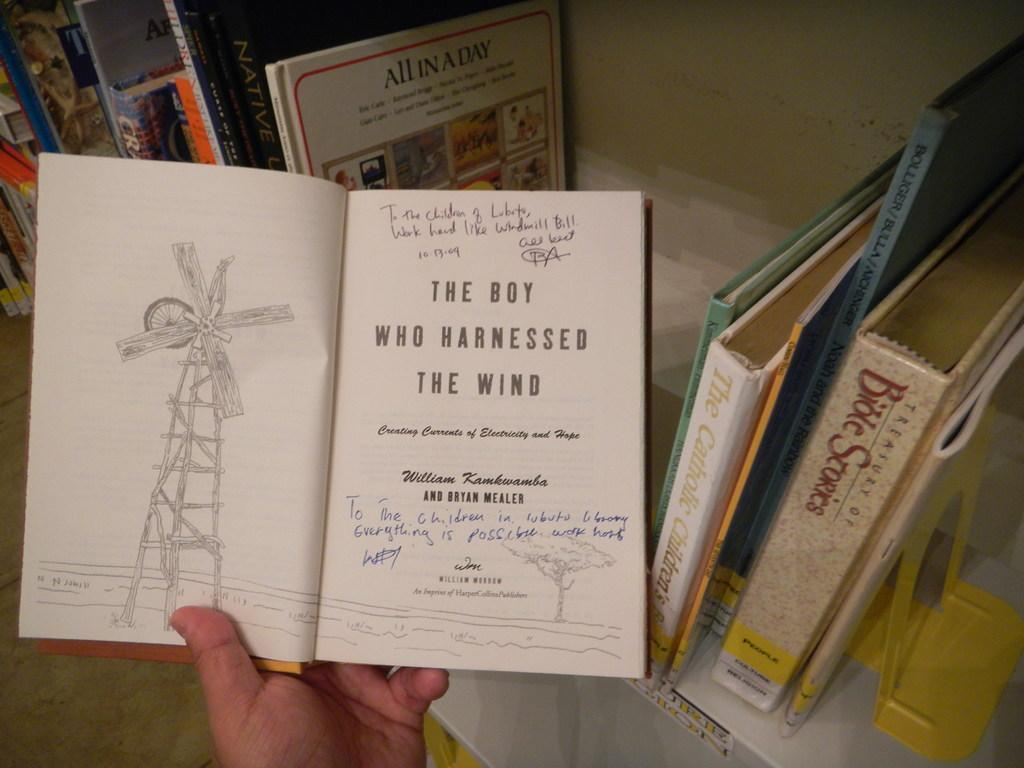Provide a one-sentence caption for the provided image. Hand is holding a book called the boy who harnessed the wind. 